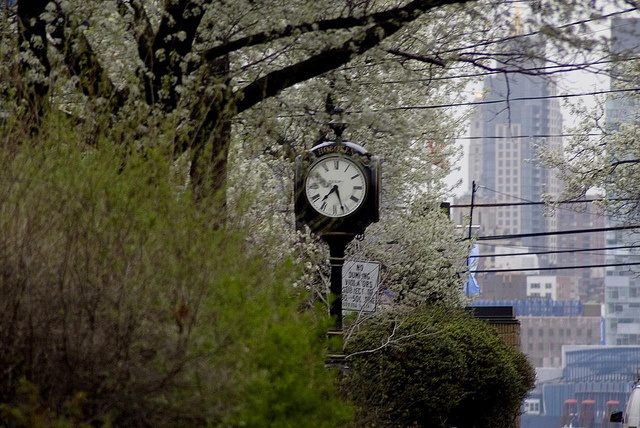Describe the objects in this image and their specific colors. I can see a clock in black, darkgray, and gray tones in this image. 